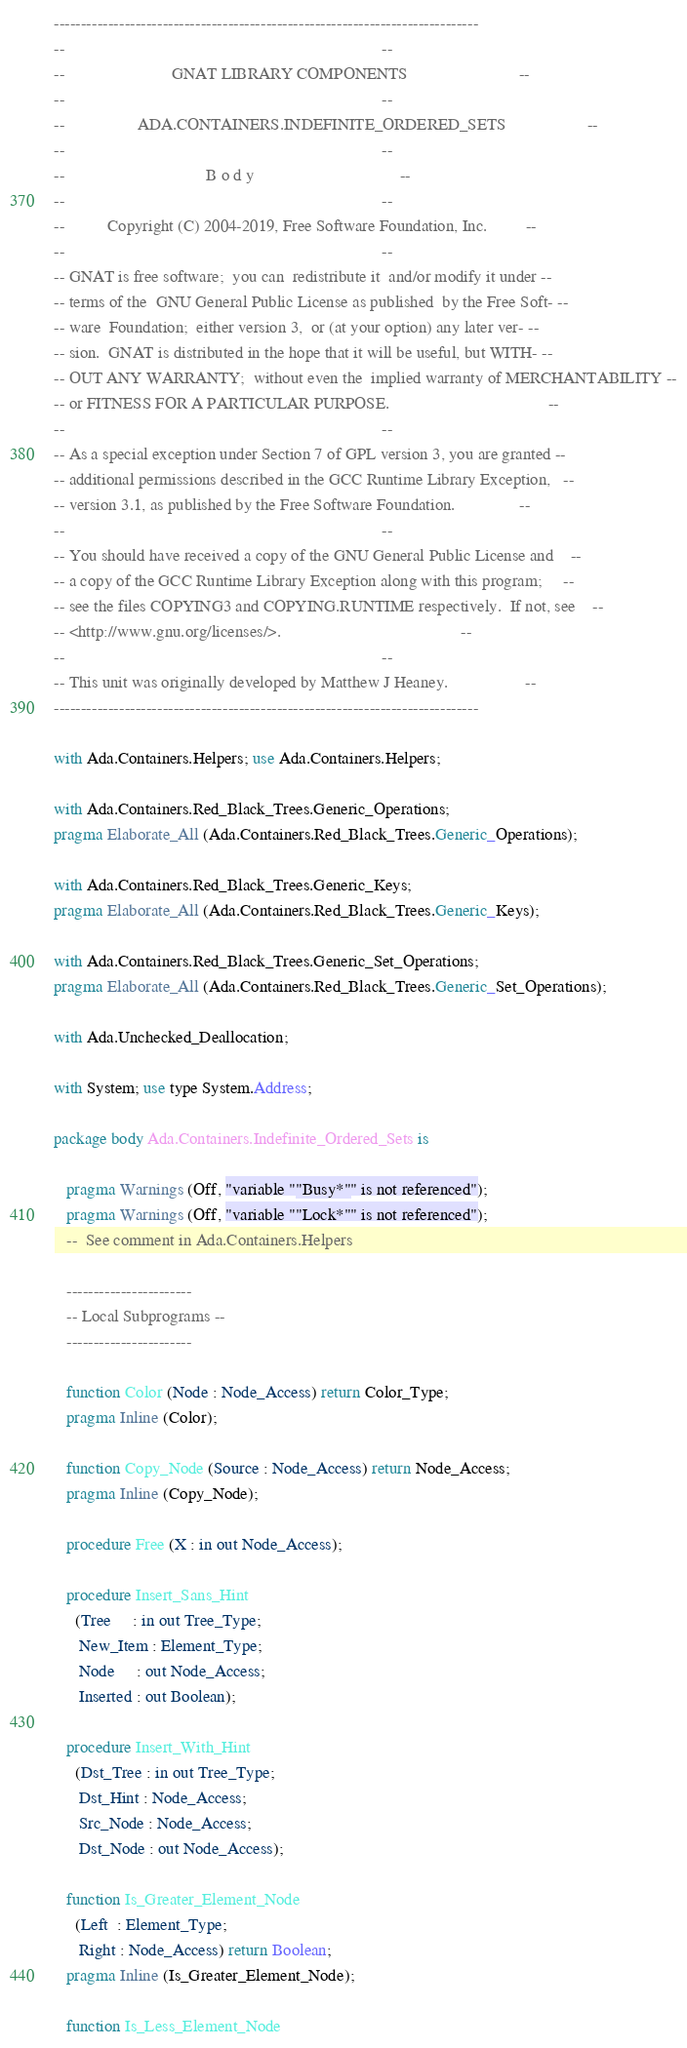<code> <loc_0><loc_0><loc_500><loc_500><_Ada_>------------------------------------------------------------------------------
--                                                                          --
--                         GNAT LIBRARY COMPONENTS                          --
--                                                                          --
--                 ADA.CONTAINERS.INDEFINITE_ORDERED_SETS                   --
--                                                                          --
--                                 B o d y                                  --
--                                                                          --
--          Copyright (C) 2004-2019, Free Software Foundation, Inc.         --
--                                                                          --
-- GNAT is free software;  you can  redistribute it  and/or modify it under --
-- terms of the  GNU General Public License as published  by the Free Soft- --
-- ware  Foundation;  either version 3,  or (at your option) any later ver- --
-- sion.  GNAT is distributed in the hope that it will be useful, but WITH- --
-- OUT ANY WARRANTY;  without even the  implied warranty of MERCHANTABILITY --
-- or FITNESS FOR A PARTICULAR PURPOSE.                                     --
--                                                                          --
-- As a special exception under Section 7 of GPL version 3, you are granted --
-- additional permissions described in the GCC Runtime Library Exception,   --
-- version 3.1, as published by the Free Software Foundation.               --
--                                                                          --
-- You should have received a copy of the GNU General Public License and    --
-- a copy of the GCC Runtime Library Exception along with this program;     --
-- see the files COPYING3 and COPYING.RUNTIME respectively.  If not, see    --
-- <http://www.gnu.org/licenses/>.                                          --
--                                                                          --
-- This unit was originally developed by Matthew J Heaney.                  --
------------------------------------------------------------------------------

with Ada.Containers.Helpers; use Ada.Containers.Helpers;

with Ada.Containers.Red_Black_Trees.Generic_Operations;
pragma Elaborate_All (Ada.Containers.Red_Black_Trees.Generic_Operations);

with Ada.Containers.Red_Black_Trees.Generic_Keys;
pragma Elaborate_All (Ada.Containers.Red_Black_Trees.Generic_Keys);

with Ada.Containers.Red_Black_Trees.Generic_Set_Operations;
pragma Elaborate_All (Ada.Containers.Red_Black_Trees.Generic_Set_Operations);

with Ada.Unchecked_Deallocation;

with System; use type System.Address;

package body Ada.Containers.Indefinite_Ordered_Sets is

   pragma Warnings (Off, "variable ""Busy*"" is not referenced");
   pragma Warnings (Off, "variable ""Lock*"" is not referenced");
   --  See comment in Ada.Containers.Helpers

   -----------------------
   -- Local Subprograms --
   -----------------------

   function Color (Node : Node_Access) return Color_Type;
   pragma Inline (Color);

   function Copy_Node (Source : Node_Access) return Node_Access;
   pragma Inline (Copy_Node);

   procedure Free (X : in out Node_Access);

   procedure Insert_Sans_Hint
     (Tree     : in out Tree_Type;
      New_Item : Element_Type;
      Node     : out Node_Access;
      Inserted : out Boolean);

   procedure Insert_With_Hint
     (Dst_Tree : in out Tree_Type;
      Dst_Hint : Node_Access;
      Src_Node : Node_Access;
      Dst_Node : out Node_Access);

   function Is_Greater_Element_Node
     (Left  : Element_Type;
      Right : Node_Access) return Boolean;
   pragma Inline (Is_Greater_Element_Node);

   function Is_Less_Element_Node</code> 